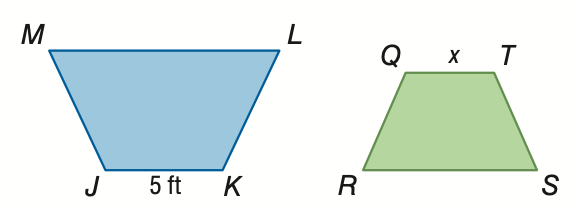Question: The area of trapezoid J K L M is 138 square feet. The area of trapezoid Q R S T is 5.52 square feet. If trapezoid J K L M \sim trapezoid Q R S T, find the scale factor from trapezoid J K L M to trapezoid Q R S T.
Choices:
A. \frac { 1 } { 25 }
B. \frac { 1 } { 5 }
C. 5
D. 25
Answer with the letter. Answer: C 